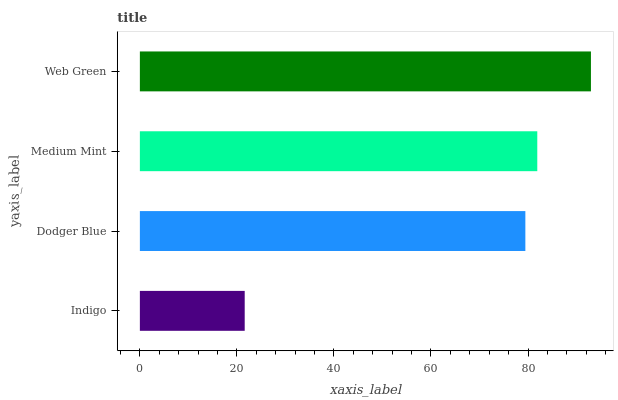Is Indigo the minimum?
Answer yes or no. Yes. Is Web Green the maximum?
Answer yes or no. Yes. Is Dodger Blue the minimum?
Answer yes or no. No. Is Dodger Blue the maximum?
Answer yes or no. No. Is Dodger Blue greater than Indigo?
Answer yes or no. Yes. Is Indigo less than Dodger Blue?
Answer yes or no. Yes. Is Indigo greater than Dodger Blue?
Answer yes or no. No. Is Dodger Blue less than Indigo?
Answer yes or no. No. Is Medium Mint the high median?
Answer yes or no. Yes. Is Dodger Blue the low median?
Answer yes or no. Yes. Is Indigo the high median?
Answer yes or no. No. Is Indigo the low median?
Answer yes or no. No. 